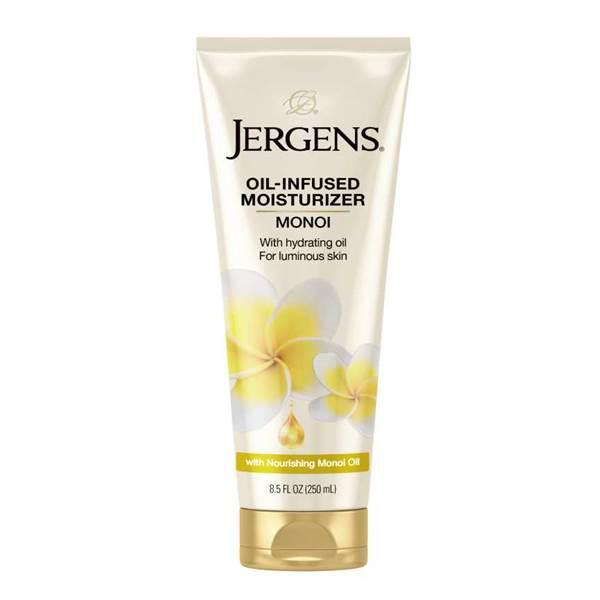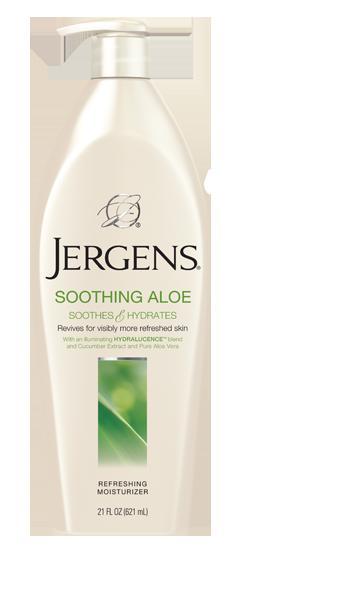The first image is the image on the left, the second image is the image on the right. Examine the images to the left and right. Is the description "There is at most, 1 lotion bottle with a green cap." accurate? Answer yes or no. No. The first image is the image on the left, the second image is the image on the right. For the images displayed, is the sentence "Both bottles have a pump-style dispenser on top." factually correct? Answer yes or no. No. 